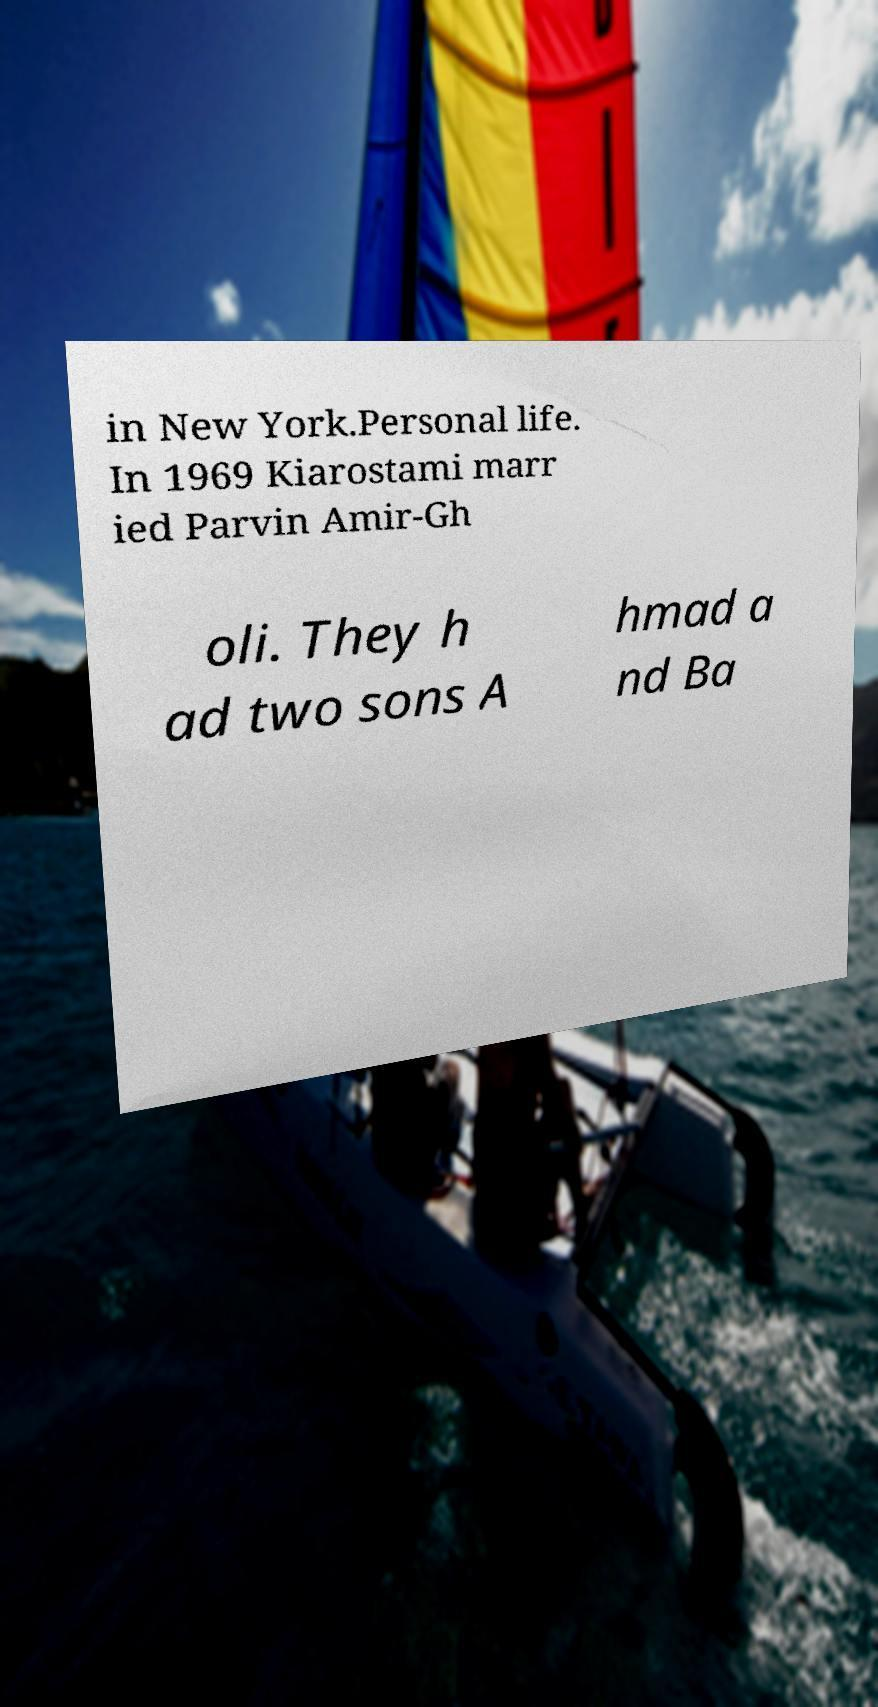Can you accurately transcribe the text from the provided image for me? in New York.Personal life. In 1969 Kiarostami marr ied Parvin Amir-Gh oli. They h ad two sons A hmad a nd Ba 